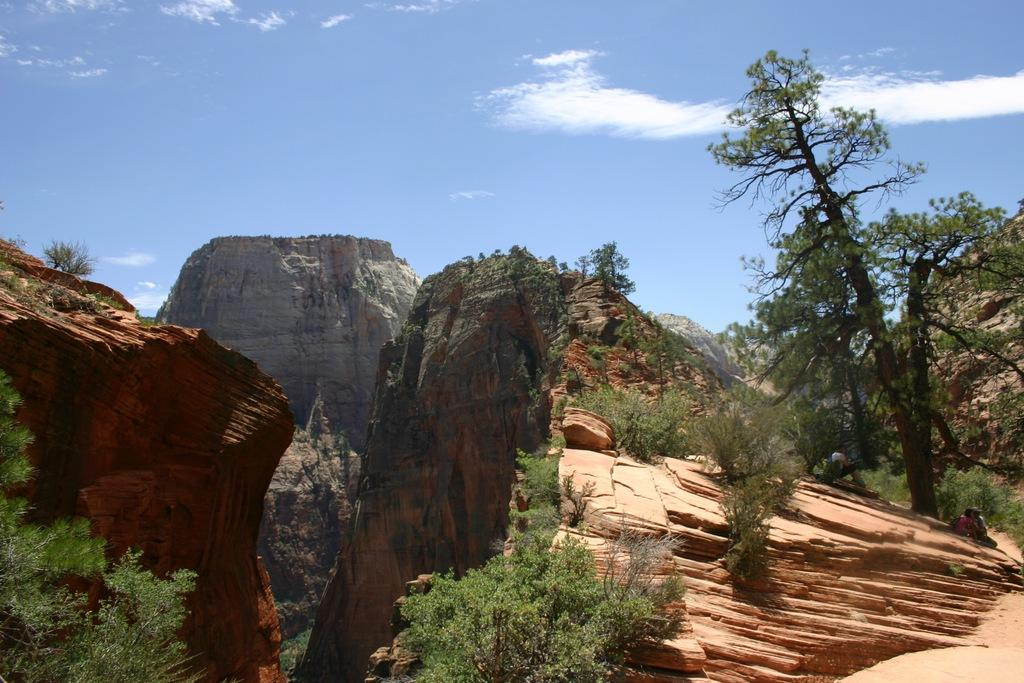Who or what can be seen in the image? There are people in the image. What type of natural feature is present in the image? There are cliffs in the image. What other natural elements can be seen in the image? There are trees and plants in the image. What can be seen in the background of the image? The sky is visible in the background of the image, and clouds are present in the sky. What invention is being demonstrated by the people in the image? There is no invention being demonstrated in the image; it simply shows people in a natural setting with cliffs, trees, plants, and a sky with clouds. 